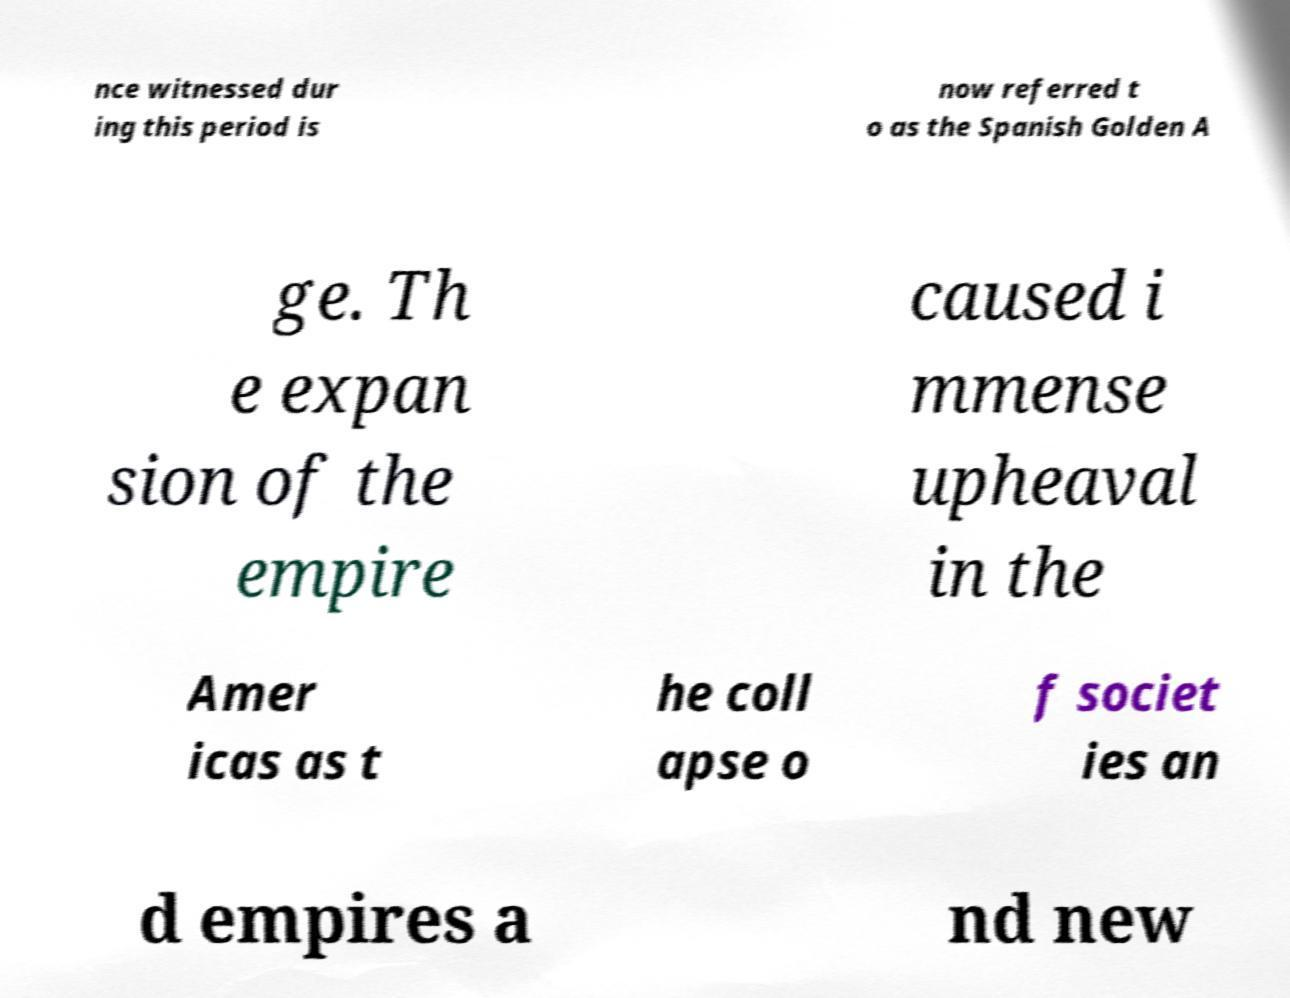There's text embedded in this image that I need extracted. Can you transcribe it verbatim? nce witnessed dur ing this period is now referred t o as the Spanish Golden A ge. Th e expan sion of the empire caused i mmense upheaval in the Amer icas as t he coll apse o f societ ies an d empires a nd new 